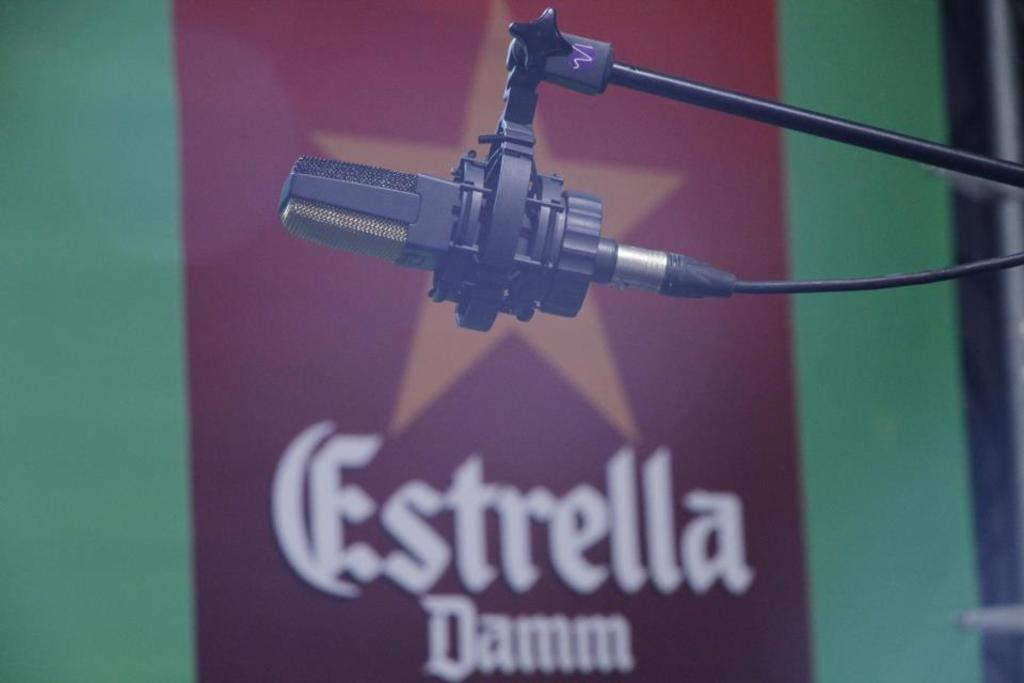What object is the main focus of the image? There is a microphone (mike) in the image. What can be seen in the background of the image? There is a banner with text and a star visible in the background of the image. What is the color of the wall in the image? There is a green color wall in the image. How does the beetle mark its territory in the image? There is no beetle present in the image, so it cannot be determined how it might mark its territory. 